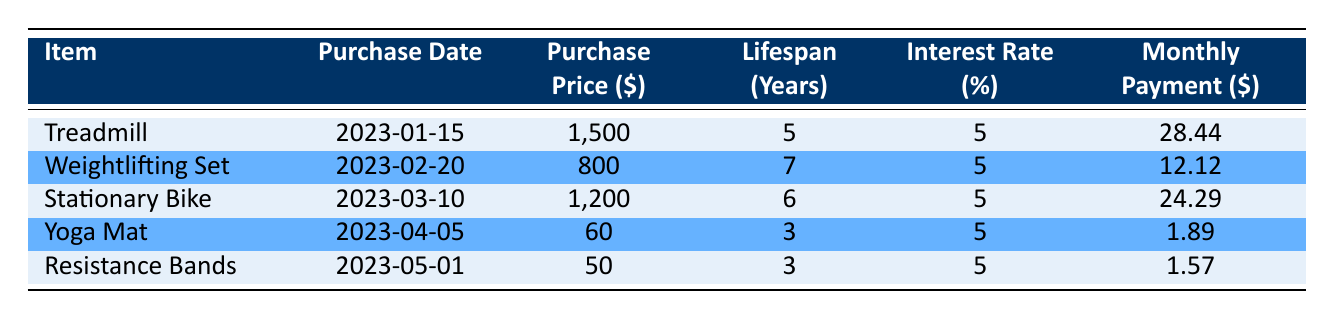What is the purchase price of the Treadmill? The purchase price of the Treadmill is listed in the table under the "Purchase Price ($)" column, next to the Treadmill's row. It shows a value of 1500.
Answer: 1500 How long is the lifespan of the Yoga Mat in years? The lifespan of the Yoga Mat can be found in the "Lifespan (Years)" column next to the Yoga Mat entry, which states 3 years.
Answer: 3 Which fitness equipment has the highest monthly payment? To find the highest monthly payment, compare the values in the "Monthly Payment ($)" column. The Treadmill has a payment of 28.44, which is greater than the others.
Answer: Treadmill What is the total purchase price for all fitness equipment? To calculate the total purchase price, sum the individual prices of all items: 1500 + 800 + 1200 + 60 + 50 = 2610.
Answer: 2610 Is the interest rate for all fitness equipment the same? The table shows that the interest rate for each item is listed as 5%, which is consistent across all entries.
Answer: Yes Which equipment has the lowest monthly payment, and what is that payment? Looking at the "Monthly Payment ($)" column, Resistance Bands have the lowest specific payment; it is 1.57.
Answer: Resistance Bands, 1.57 How many years of lifespan do you get on average from the fitness equipment purchased? To calculate the average lifespan, sum the lifespans: 5 + 7 + 6 + 3 + 3 = 24, then divide by the number of items (5): 24/5 = 4.8 years.
Answer: 4.8 If I were to purchase only the Weightlifting Set and the Yoga Mat, what would be the total monthly payment? The monthly payments are 12.12 for the Weightlifting Set and 1.89 for the Yoga Mat. Adding these gives 12.12 + 1.89 = 14.01.
Answer: 14.01 Which item was purchased first, and what is its purchase date? By examining the "Purchase Date" column, the Treadmill has the earliest date of 2023-01-15, indicating it was purchased first.
Answer: Treadmill, 2023-01-15 